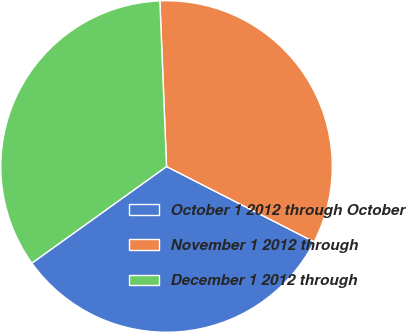<chart> <loc_0><loc_0><loc_500><loc_500><pie_chart><fcel>October 1 2012 through October<fcel>November 1 2012 through<fcel>December 1 2012 through<nl><fcel>32.58%<fcel>33.15%<fcel>34.26%<nl></chart> 